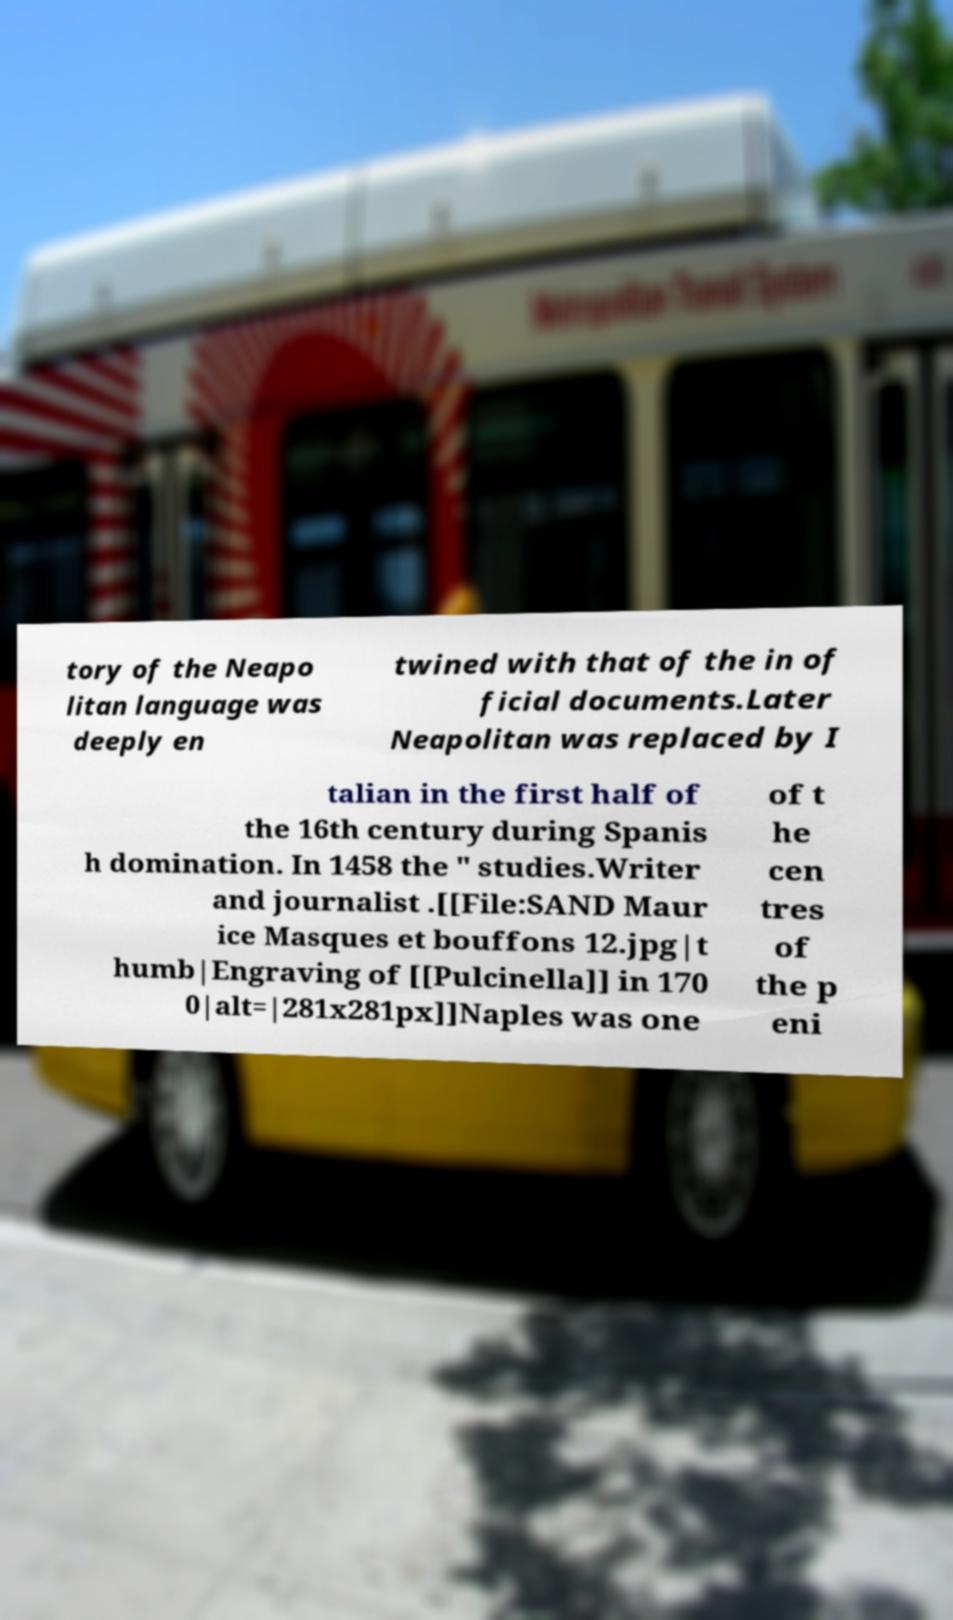Can you read and provide the text displayed in the image?This photo seems to have some interesting text. Can you extract and type it out for me? tory of the Neapo litan language was deeply en twined with that of the in of ficial documents.Later Neapolitan was replaced by I talian in the first half of the 16th century during Spanis h domination. In 1458 the " studies.Writer and journalist .[[File:SAND Maur ice Masques et bouffons 12.jpg|t humb|Engraving of [[Pulcinella]] in 170 0|alt=|281x281px]]Naples was one of t he cen tres of the p eni 